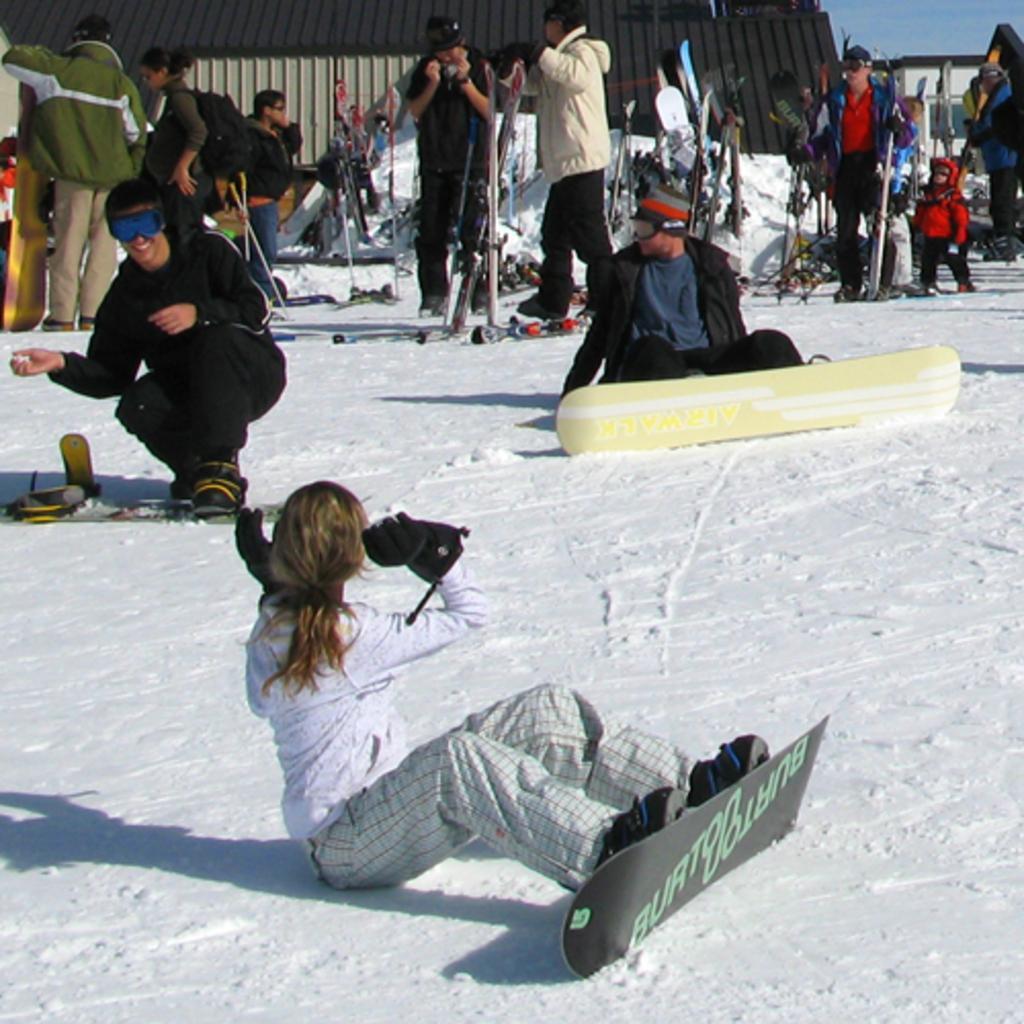Please provide a concise description of this image. In this picture there is a woman who is wearing gloves, shirt and skateboard. On the left we can see a man who is wearing black dress. In the background we can see the group of persons who are holding the snowboard. At the top we can see the building. At the top right corner there is a sky. 